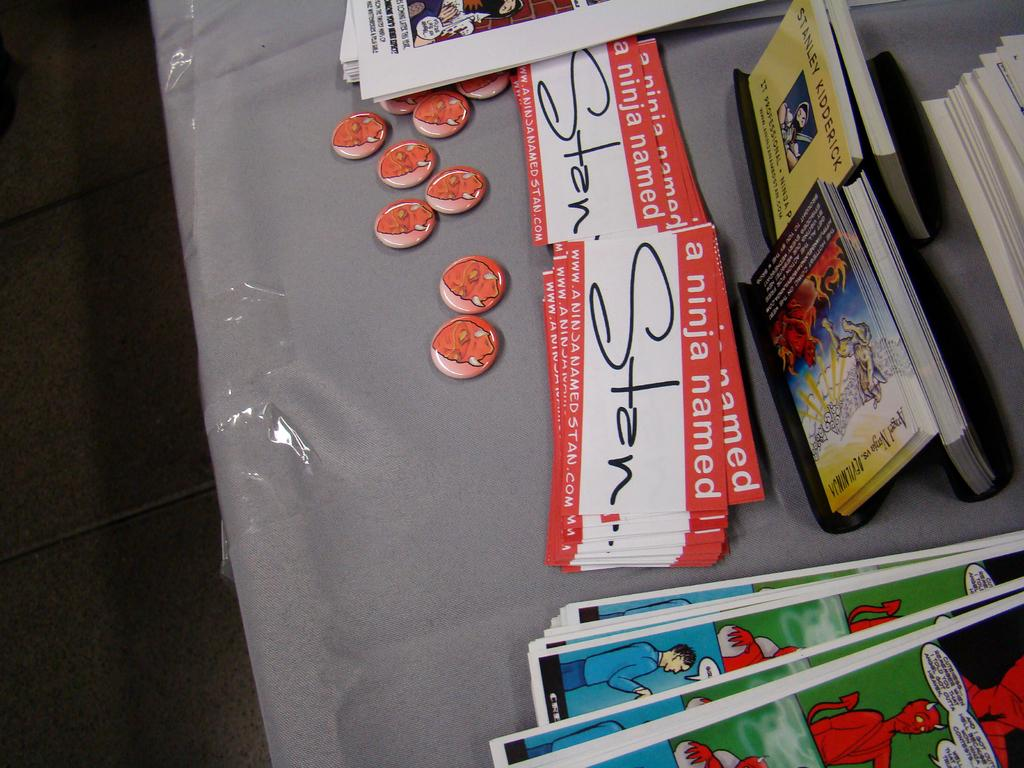<image>
Write a terse but informative summary of the picture. "A Ninja named" name tags on a table with names on it. 